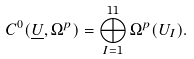Convert formula to latex. <formula><loc_0><loc_0><loc_500><loc_500>C ^ { 0 } ( \underline { U } , \Omega ^ { p } ) = \bigoplus _ { I = 1 } ^ { 1 1 } \Omega ^ { p } ( U _ { I } ) .</formula> 